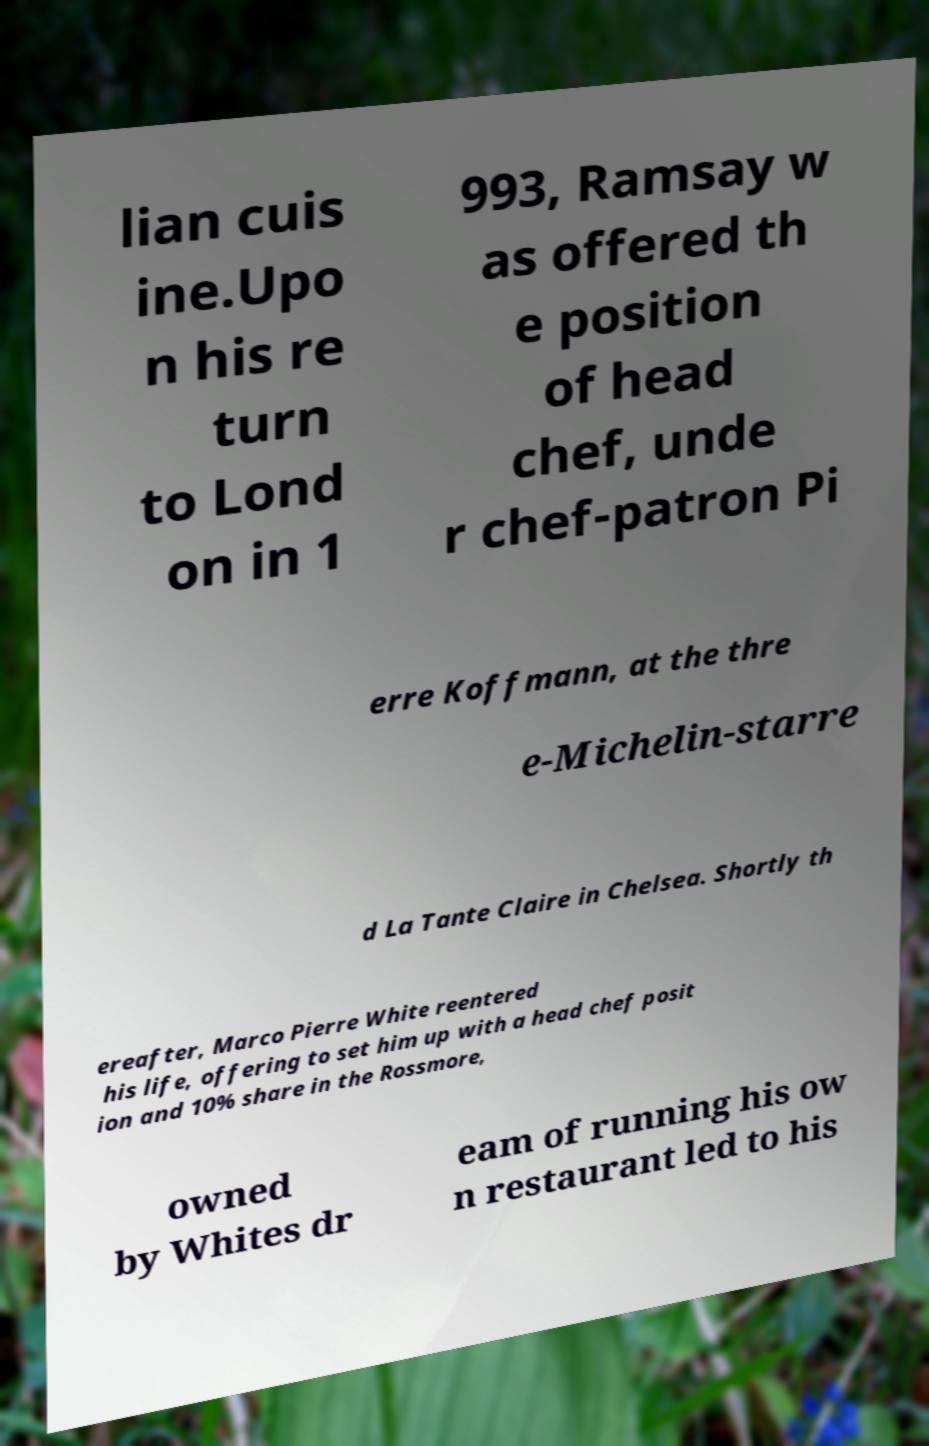For documentation purposes, I need the text within this image transcribed. Could you provide that? lian cuis ine.Upo n his re turn to Lond on in 1 993, Ramsay w as offered th e position of head chef, unde r chef-patron Pi erre Koffmann, at the thre e-Michelin-starre d La Tante Claire in Chelsea. Shortly th ereafter, Marco Pierre White reentered his life, offering to set him up with a head chef posit ion and 10% share in the Rossmore, owned by Whites dr eam of running his ow n restaurant led to his 